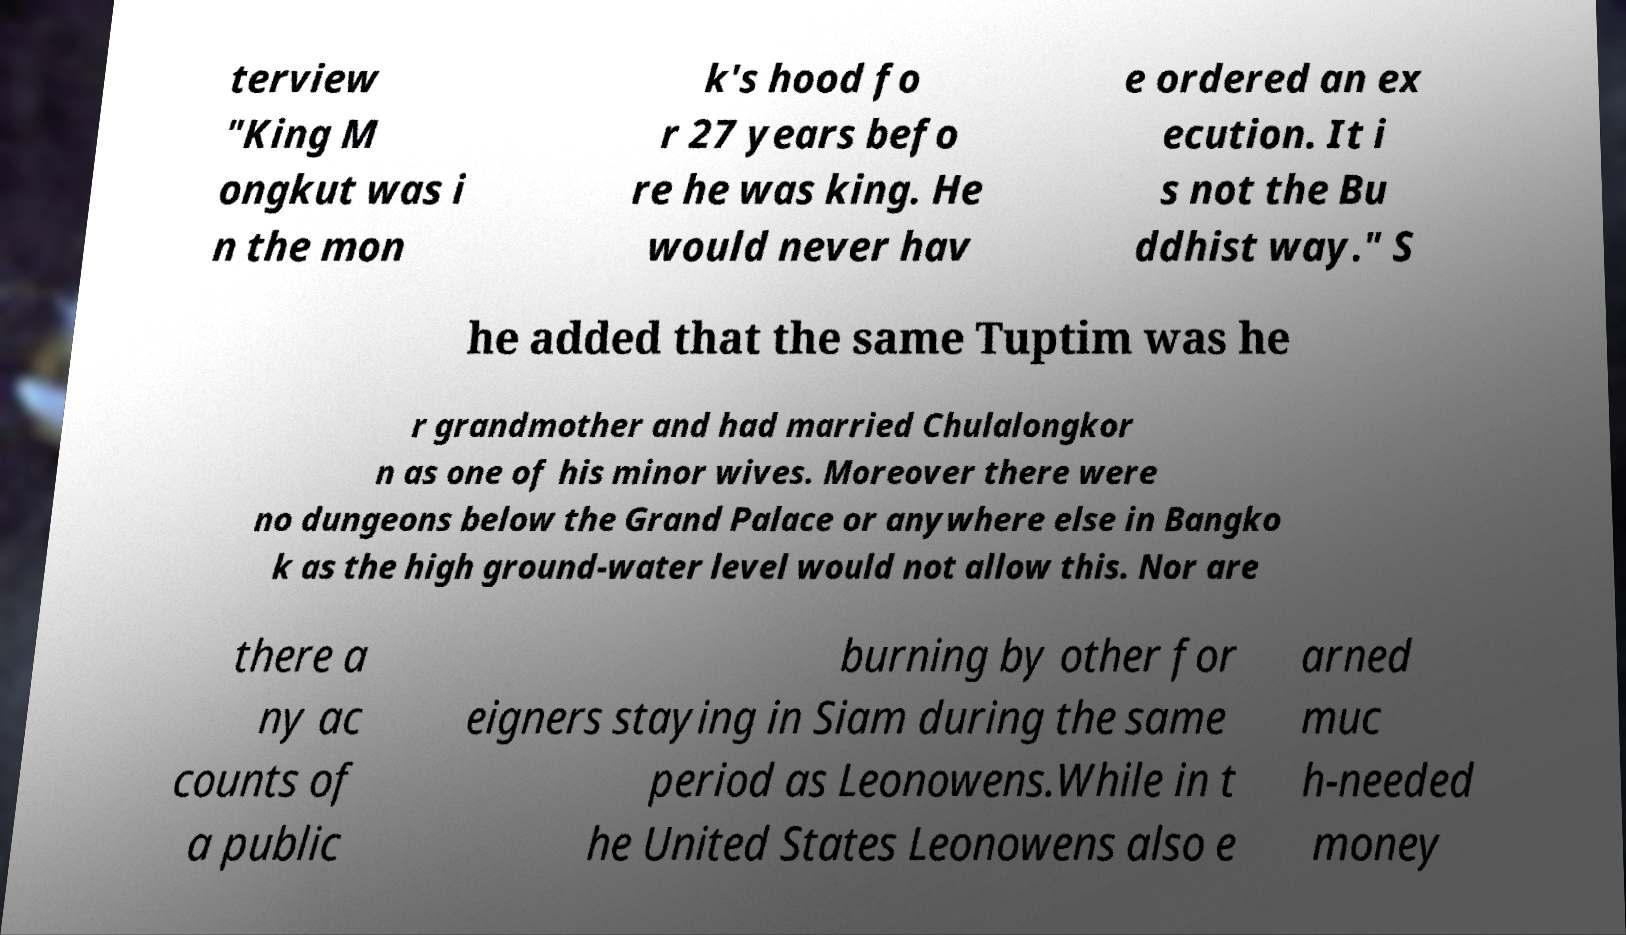Can you accurately transcribe the text from the provided image for me? terview "King M ongkut was i n the mon k's hood fo r 27 years befo re he was king. He would never hav e ordered an ex ecution. It i s not the Bu ddhist way." S he added that the same Tuptim was he r grandmother and had married Chulalongkor n as one of his minor wives. Moreover there were no dungeons below the Grand Palace or anywhere else in Bangko k as the high ground-water level would not allow this. Nor are there a ny ac counts of a public burning by other for eigners staying in Siam during the same period as Leonowens.While in t he United States Leonowens also e arned muc h-needed money 